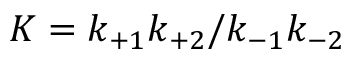Convert formula to latex. <formula><loc_0><loc_0><loc_500><loc_500>K = k _ { + 1 } k _ { + 2 } / k _ { - 1 } k _ { - 2 }</formula> 